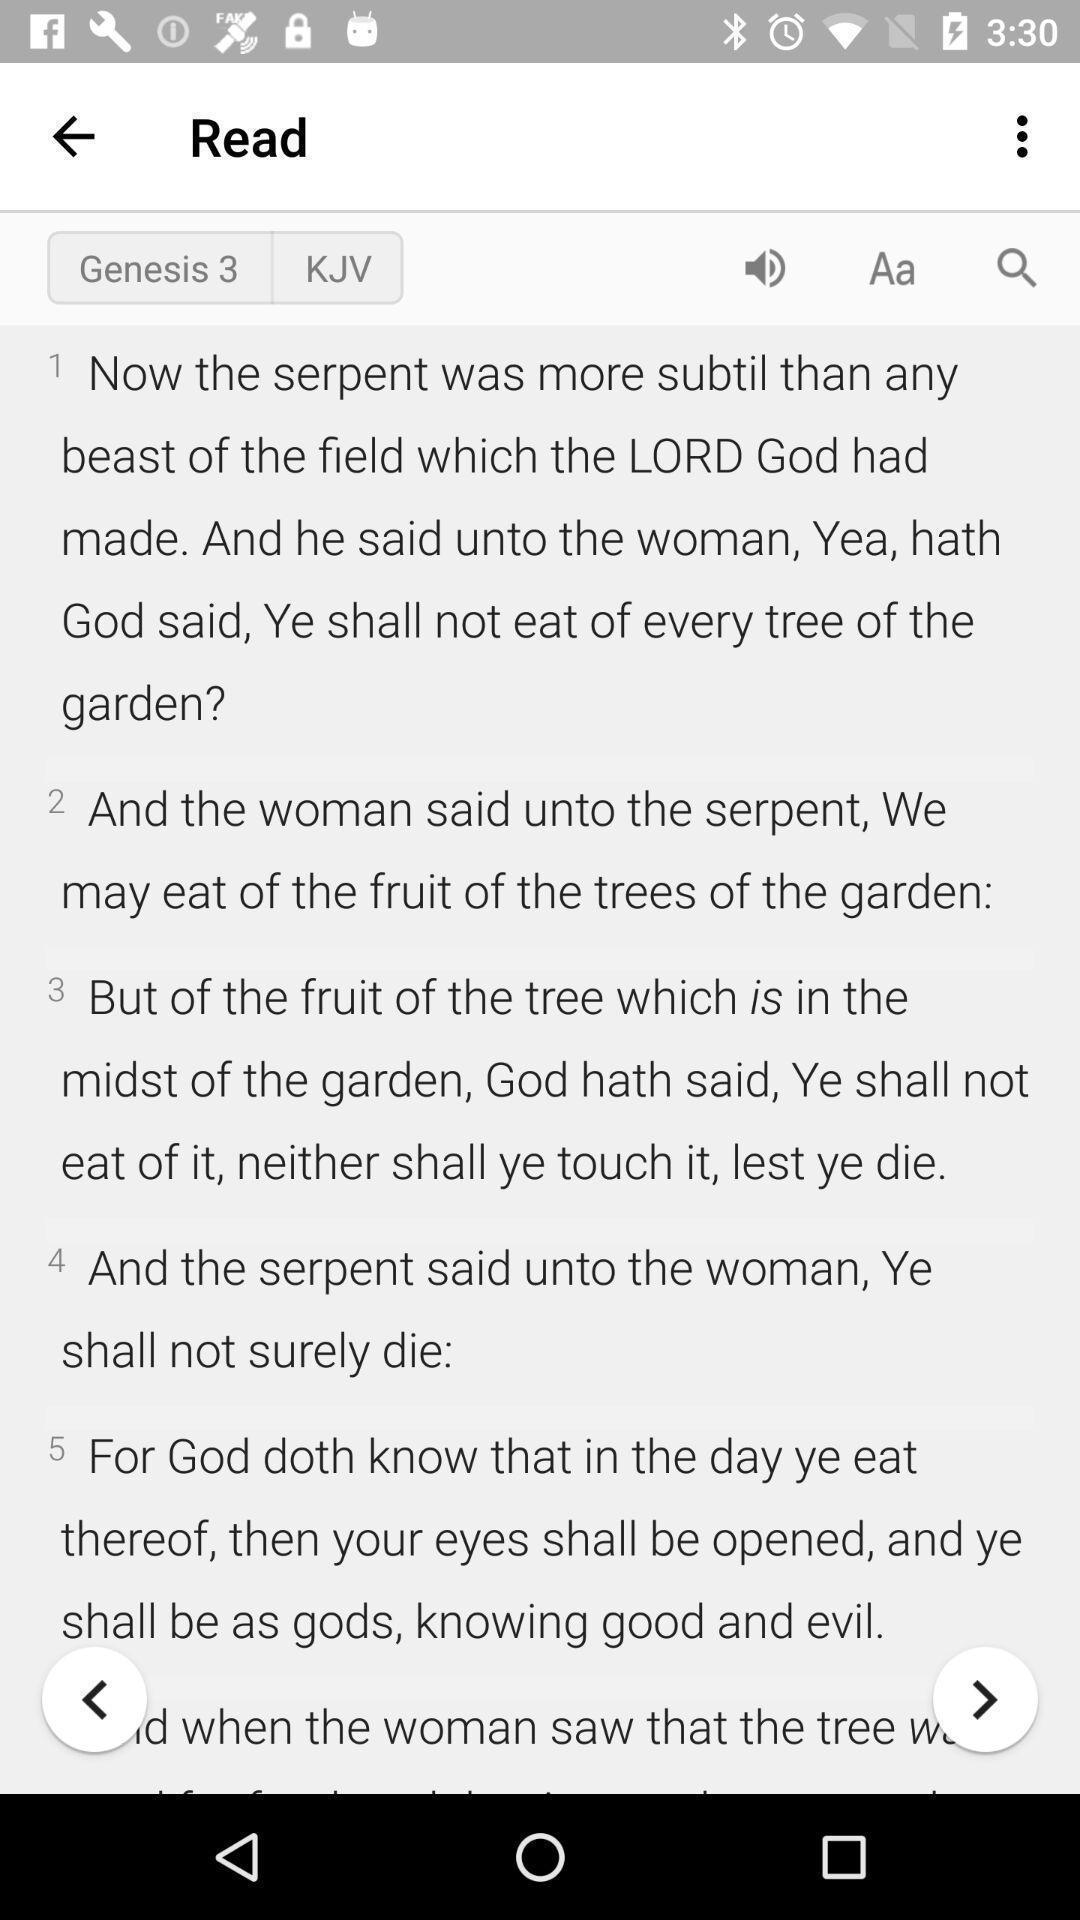Summarize the information in this screenshot. Page for reading a story. 